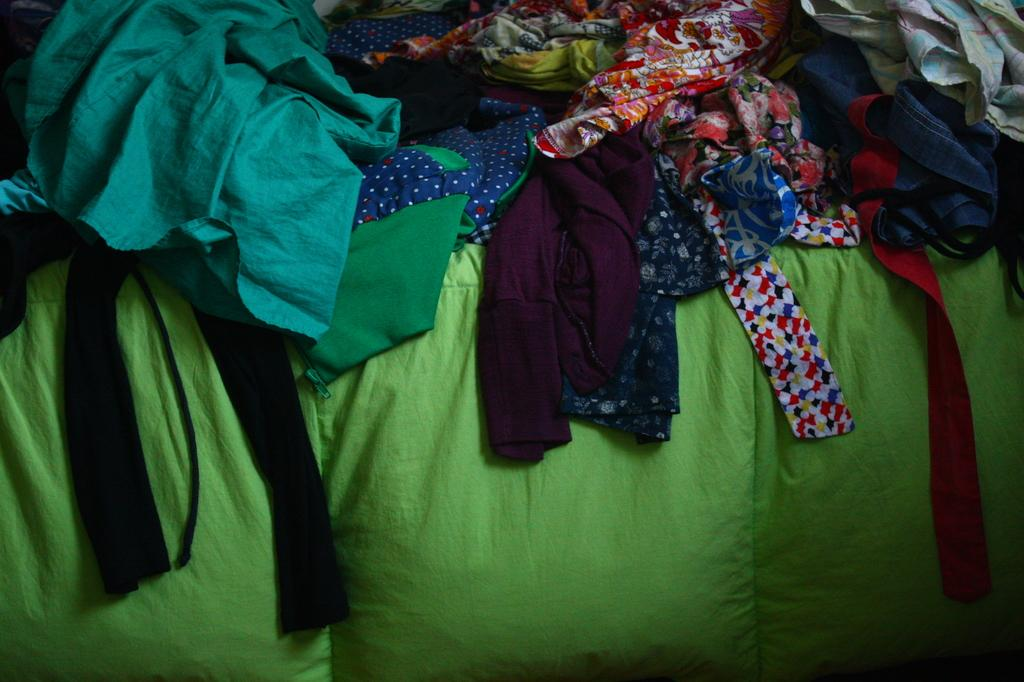What is the main subject of the image? The main subject of the image is a group of clothes. Can you describe the clothes in the image? Unfortunately, the facts provided do not give any details about the clothes, so we cannot describe them. What type of drink is being served in the image? There is no drink present in the image; it only features a group of clothes. Is there any steam coming from the clothes in the image? There is no steam present in the image; it only features a group of clothes. 